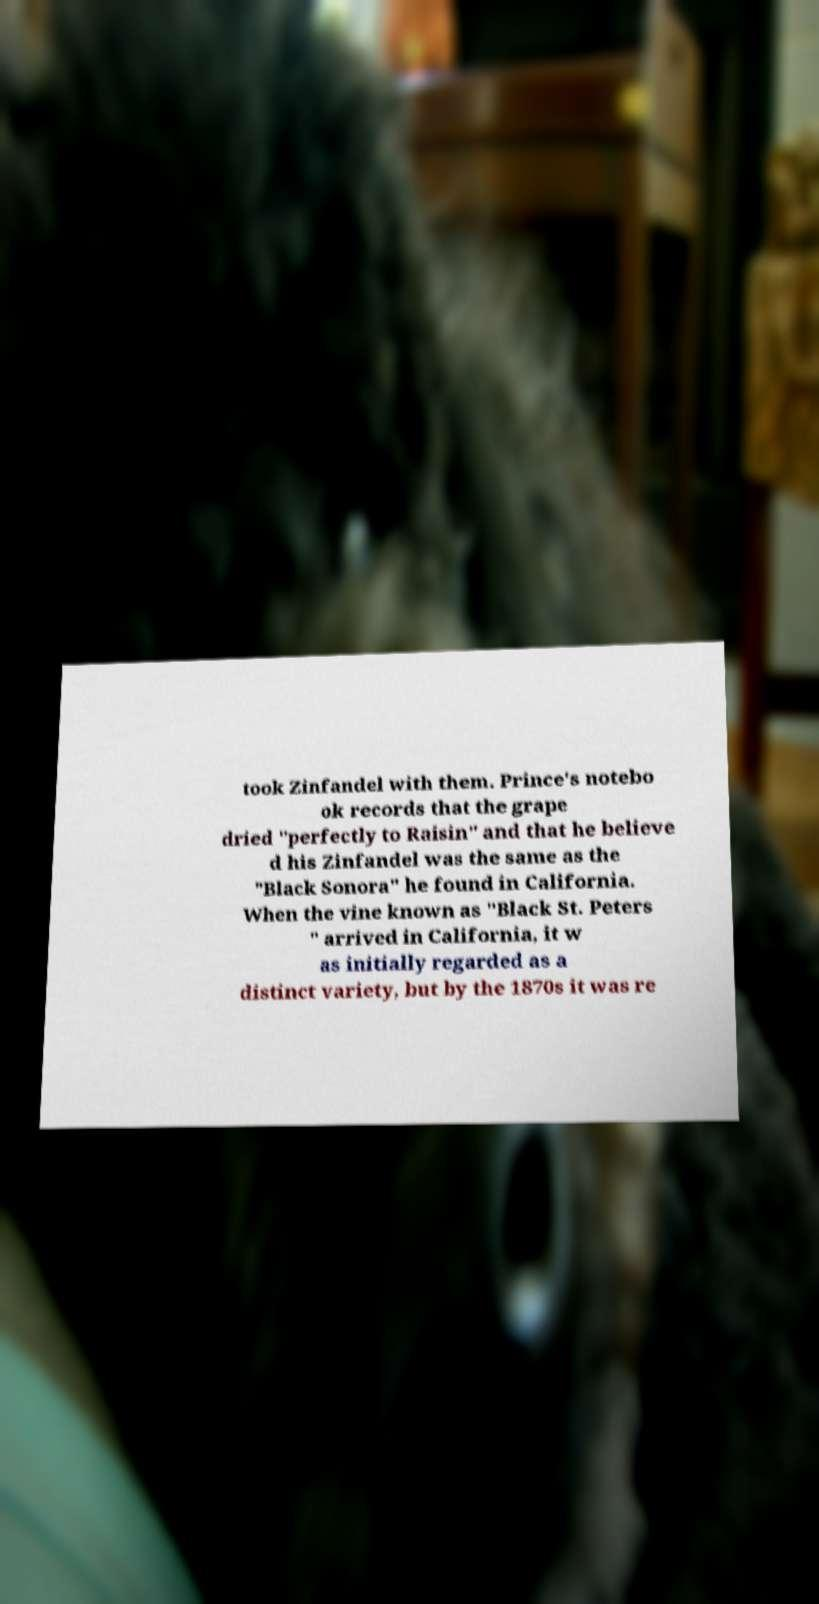Could you extract and type out the text from this image? took Zinfandel with them. Prince's notebo ok records that the grape dried "perfectly to Raisin" and that he believe d his Zinfandel was the same as the "Black Sonora" he found in California. When the vine known as "Black St. Peters " arrived in California, it w as initially regarded as a distinct variety, but by the 1870s it was re 